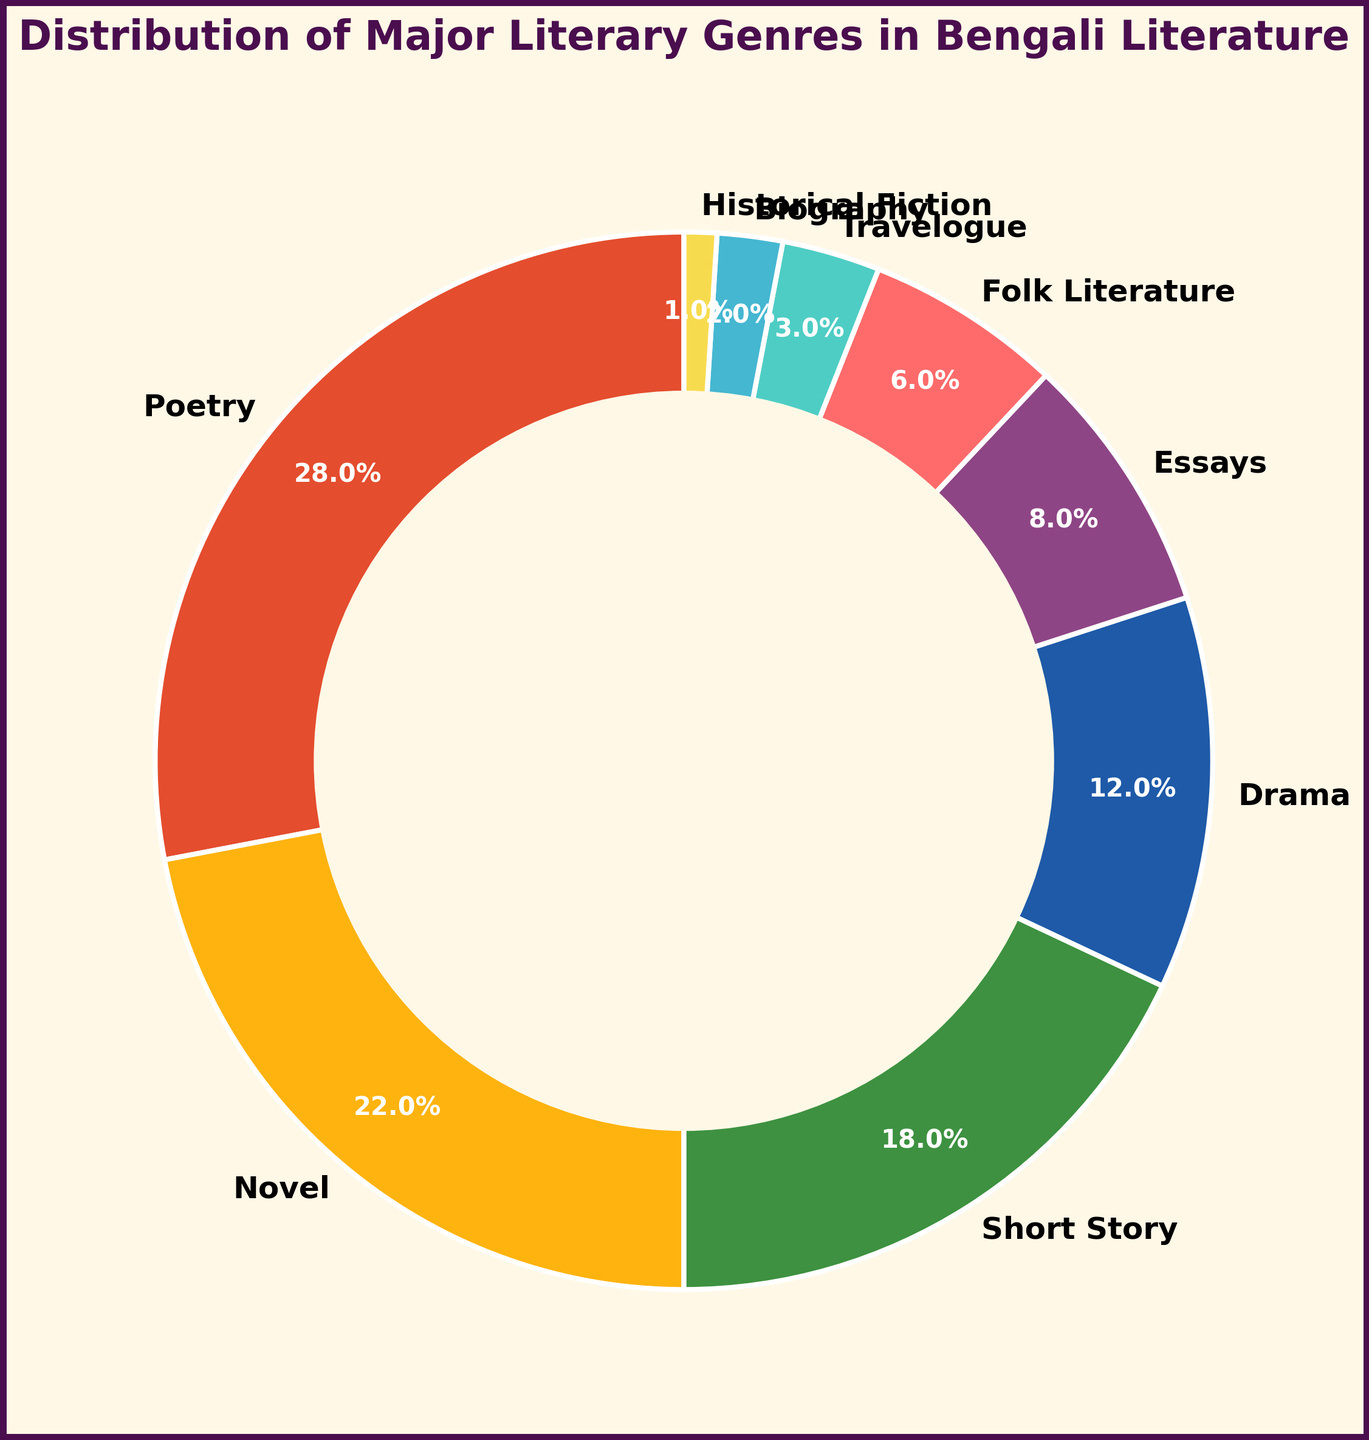What is the largest genre represented in the pie chart? To find the largest genre, look at the segment that has the largest percentage. From the figure, the largest segment is Poetry with 28%.
Answer: Poetry Which two genres combined account for more than 40% of the distribution? Adding the percentages of the two largest genres, Poetry (28%) and Novel (22%), gives 50%, which is more than 40%.
Answer: Poetry and Novel What is the total percentage of the least three represented genres? To find this, sum the percentages of Biography (2%), Historical Fiction (1%), and Travelogue (3%). The total is 2% + 1% + 3% = 6%.
Answer: 6% Is the percentage of Drama greater than Essays? By comparing the percentages of Drama (12%) and Essays (8%), Drama's percentage is indeed greater than that of Essays.
Answer: Yes What is the percentage difference between the percentages of Short Story and Drama? To find the difference, subtract Drama's percentage from Short Story's: 18% - 12% = 6%.
Answer: 6% What color represents the Novel genre in the pie chart? Observing the pie chart, the segment representing Novel is colored yellow.
Answer: Yellow Which genre is represented by a green segment, and what is its percentage? From the pie chart, the green segment represents the Short Story genre, with a percentage of 18%.
Answer: Short Story, 18% If you combine the percentages for Folk Literature and Travelogue, is their combined percentage greater than that of Poetry? Summing Folk Literature (6%) and Travelogue (3%) gives 6% + 3% = 9%, which is less than 28%.
Answer: No Which genre has exactly half the percentage of Drama? Drama's percentage is 12%, and half of that is 6%. The genre with 6% is Folk Literature.
Answer: Folk Literature How many genres have a percentage of 10% or higher? The genres with percentages of 10% or higher are Poetry (28%), Novel (22%), Short Story (18%), and Drama (12%). There are 4 such genres.
Answer: 4 